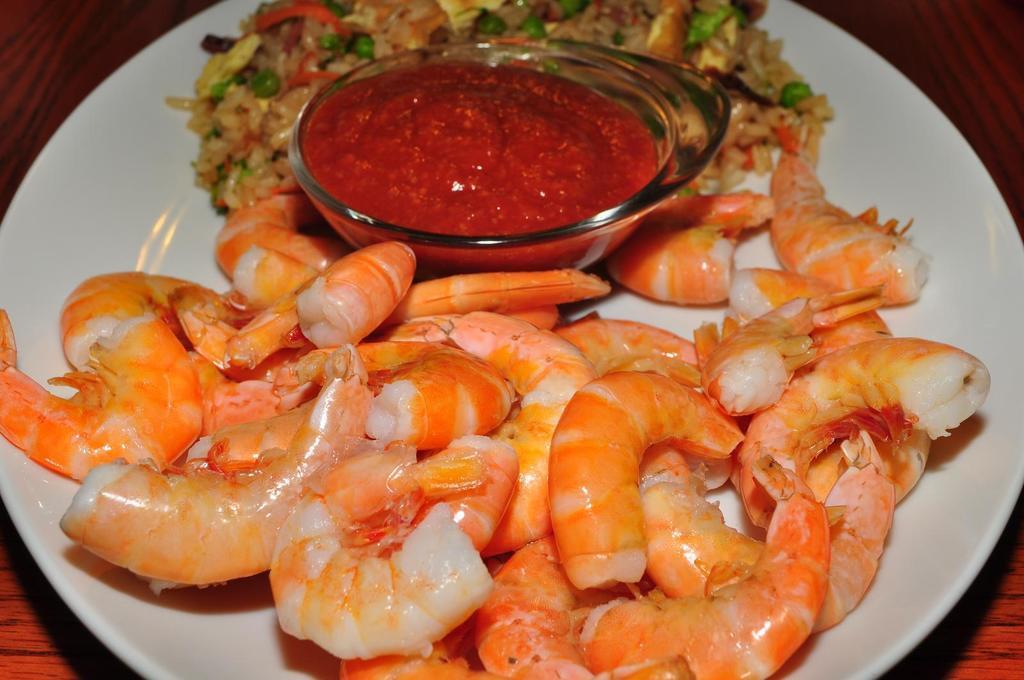Could you give a brief overview of what you see in this image? In the center of the image a table is present. On the table we can see a plate of prawns, a bowl of ketchup and fried rice are present. 